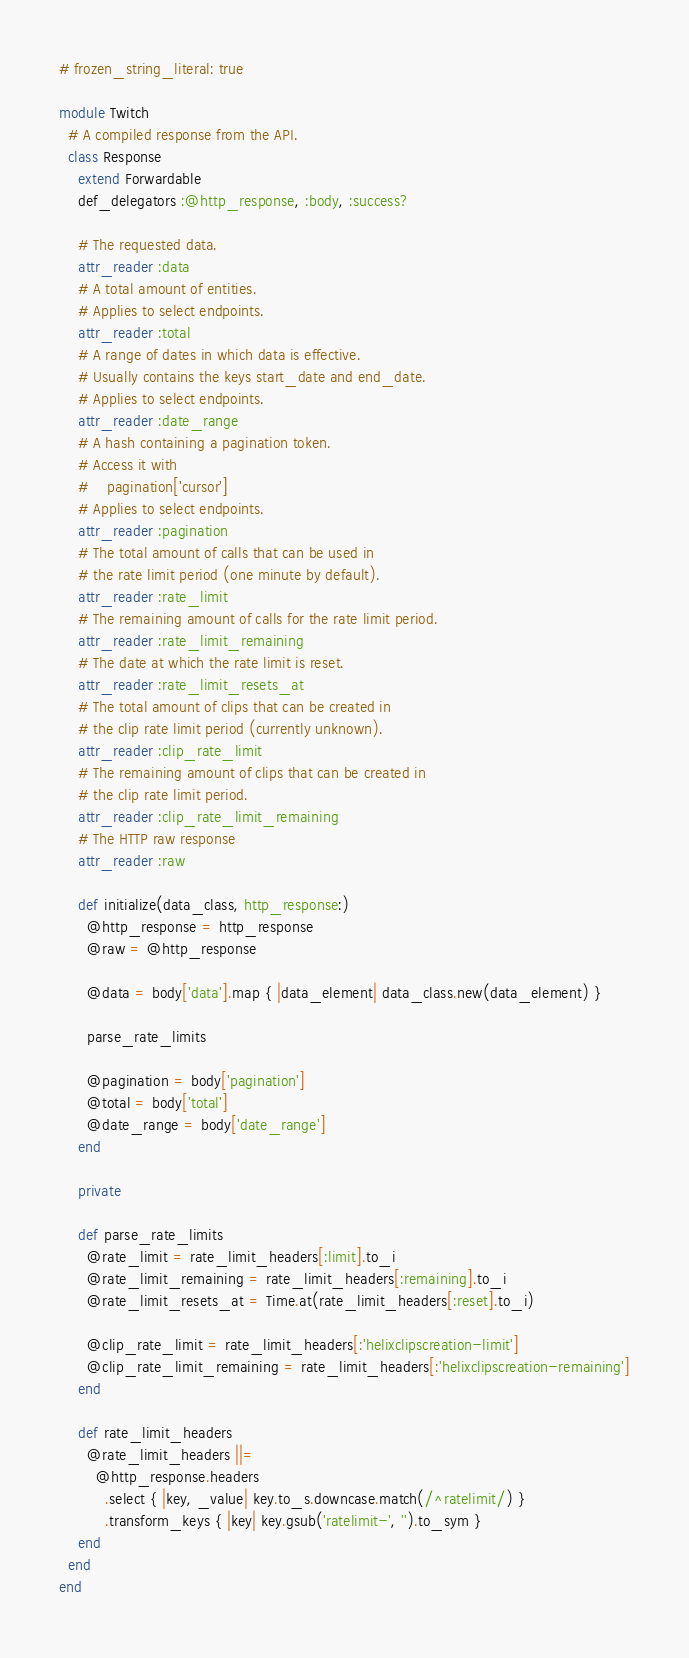Convert code to text. <code><loc_0><loc_0><loc_500><loc_500><_Ruby_># frozen_string_literal: true

module Twitch
  # A compiled response from the API.
  class Response
    extend Forwardable
    def_delegators :@http_response, :body, :success?

    # The requested data.
    attr_reader :data
    # A total amount of entities.
    # Applies to select endpoints.
    attr_reader :total
    # A range of dates in which data is effective.
    # Usually contains the keys start_date and end_date.
    # Applies to select endpoints.
    attr_reader :date_range
    # A hash containing a pagination token.
    # Access it with
    #    pagination['cursor']
    # Applies to select endpoints.
    attr_reader :pagination
    # The total amount of calls that can be used in
    # the rate limit period (one minute by default).
    attr_reader :rate_limit
    # The remaining amount of calls for the rate limit period.
    attr_reader :rate_limit_remaining
    # The date at which the rate limit is reset.
    attr_reader :rate_limit_resets_at
    # The total amount of clips that can be created in
    # the clip rate limit period (currently unknown).
    attr_reader :clip_rate_limit
    # The remaining amount of clips that can be created in
    # the clip rate limit period.
    attr_reader :clip_rate_limit_remaining
    # The HTTP raw response
    attr_reader :raw

    def initialize(data_class, http_response:)
      @http_response = http_response
      @raw = @http_response

      @data = body['data'].map { |data_element| data_class.new(data_element) }

      parse_rate_limits

      @pagination = body['pagination']
      @total = body['total']
      @date_range = body['date_range']
    end

    private

    def parse_rate_limits
      @rate_limit = rate_limit_headers[:limit].to_i
      @rate_limit_remaining = rate_limit_headers[:remaining].to_i
      @rate_limit_resets_at = Time.at(rate_limit_headers[:reset].to_i)

      @clip_rate_limit = rate_limit_headers[:'helixclipscreation-limit']
      @clip_rate_limit_remaining = rate_limit_headers[:'helixclipscreation-remaining']
    end

    def rate_limit_headers
      @rate_limit_headers ||=
        @http_response.headers
          .select { |key, _value| key.to_s.downcase.match(/^ratelimit/) }
          .transform_keys { |key| key.gsub('ratelimit-', '').to_sym }
    end
  end
end
</code> 